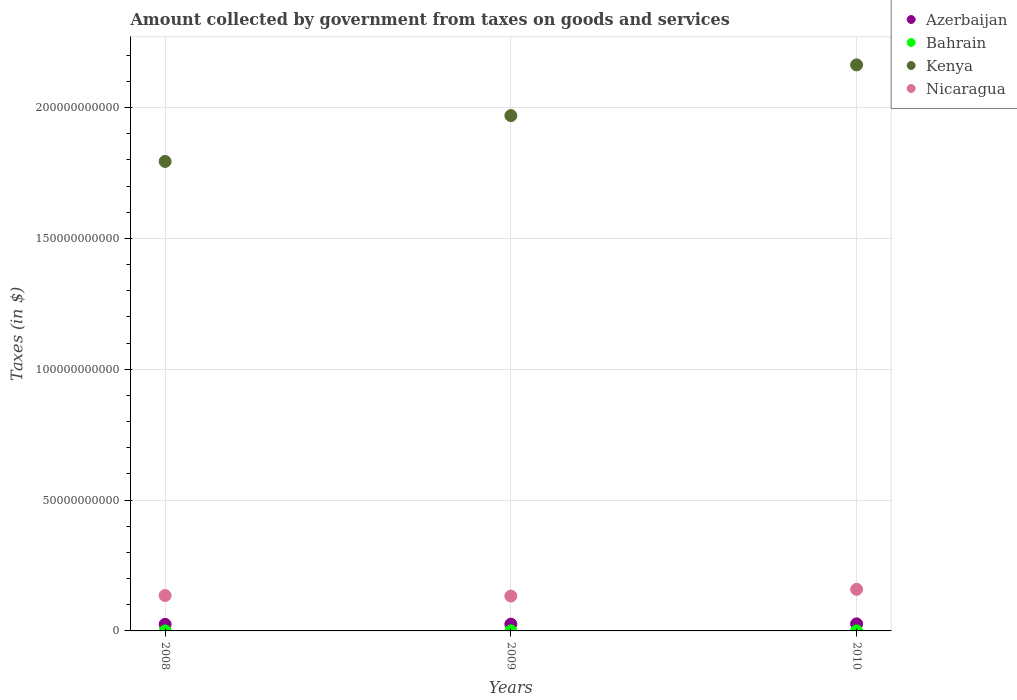How many different coloured dotlines are there?
Offer a terse response. 4. What is the amount collected by government from taxes on goods and services in Bahrain in 2009?
Your response must be concise. 2.07e+07. Across all years, what is the maximum amount collected by government from taxes on goods and services in Nicaragua?
Your answer should be compact. 1.59e+1. Across all years, what is the minimum amount collected by government from taxes on goods and services in Bahrain?
Your response must be concise. 3.32e+06. What is the total amount collected by government from taxes on goods and services in Bahrain in the graph?
Offer a very short reply. 3.67e+07. What is the difference between the amount collected by government from taxes on goods and services in Kenya in 2009 and that in 2010?
Provide a succinct answer. -1.94e+1. What is the difference between the amount collected by government from taxes on goods and services in Nicaragua in 2009 and the amount collected by government from taxes on goods and services in Bahrain in 2008?
Make the answer very short. 1.33e+1. What is the average amount collected by government from taxes on goods and services in Azerbaijan per year?
Give a very brief answer. 2.60e+09. In the year 2010, what is the difference between the amount collected by government from taxes on goods and services in Kenya and amount collected by government from taxes on goods and services in Azerbaijan?
Give a very brief answer. 2.14e+11. What is the ratio of the amount collected by government from taxes on goods and services in Kenya in 2008 to that in 2009?
Keep it short and to the point. 0.91. What is the difference between the highest and the second highest amount collected by government from taxes on goods and services in Nicaragua?
Your answer should be very brief. 2.37e+09. What is the difference between the highest and the lowest amount collected by government from taxes on goods and services in Azerbaijan?
Keep it short and to the point. 1.93e+08. Is it the case that in every year, the sum of the amount collected by government from taxes on goods and services in Nicaragua and amount collected by government from taxes on goods and services in Azerbaijan  is greater than the sum of amount collected by government from taxes on goods and services in Kenya and amount collected by government from taxes on goods and services in Bahrain?
Offer a very short reply. Yes. Are the values on the major ticks of Y-axis written in scientific E-notation?
Offer a terse response. No. Does the graph contain any zero values?
Keep it short and to the point. No. Where does the legend appear in the graph?
Your answer should be very brief. Top right. How many legend labels are there?
Make the answer very short. 4. How are the legend labels stacked?
Your answer should be compact. Vertical. What is the title of the graph?
Offer a terse response. Amount collected by government from taxes on goods and services. What is the label or title of the X-axis?
Offer a very short reply. Years. What is the label or title of the Y-axis?
Give a very brief answer. Taxes (in $). What is the Taxes (in $) of Azerbaijan in 2008?
Offer a terse response. 2.50e+09. What is the Taxes (in $) in Bahrain in 2008?
Offer a terse response. 3.32e+06. What is the Taxes (in $) of Kenya in 2008?
Provide a succinct answer. 1.79e+11. What is the Taxes (in $) of Nicaragua in 2008?
Your answer should be compact. 1.35e+1. What is the Taxes (in $) in Azerbaijan in 2009?
Provide a short and direct response. 2.59e+09. What is the Taxes (in $) of Bahrain in 2009?
Give a very brief answer. 2.07e+07. What is the Taxes (in $) in Kenya in 2009?
Ensure brevity in your answer.  1.97e+11. What is the Taxes (in $) of Nicaragua in 2009?
Your response must be concise. 1.33e+1. What is the Taxes (in $) in Azerbaijan in 2010?
Offer a terse response. 2.70e+09. What is the Taxes (in $) in Bahrain in 2010?
Your response must be concise. 1.27e+07. What is the Taxes (in $) in Kenya in 2010?
Your answer should be compact. 2.16e+11. What is the Taxes (in $) in Nicaragua in 2010?
Provide a short and direct response. 1.59e+1. Across all years, what is the maximum Taxes (in $) in Azerbaijan?
Offer a very short reply. 2.70e+09. Across all years, what is the maximum Taxes (in $) in Bahrain?
Your response must be concise. 2.07e+07. Across all years, what is the maximum Taxes (in $) of Kenya?
Offer a very short reply. 2.16e+11. Across all years, what is the maximum Taxes (in $) of Nicaragua?
Give a very brief answer. 1.59e+1. Across all years, what is the minimum Taxes (in $) in Azerbaijan?
Give a very brief answer. 2.50e+09. Across all years, what is the minimum Taxes (in $) of Bahrain?
Your answer should be very brief. 3.32e+06. Across all years, what is the minimum Taxes (in $) of Kenya?
Your answer should be compact. 1.79e+11. Across all years, what is the minimum Taxes (in $) of Nicaragua?
Make the answer very short. 1.33e+1. What is the total Taxes (in $) in Azerbaijan in the graph?
Ensure brevity in your answer.  7.79e+09. What is the total Taxes (in $) of Bahrain in the graph?
Ensure brevity in your answer.  3.67e+07. What is the total Taxes (in $) of Kenya in the graph?
Provide a succinct answer. 5.93e+11. What is the total Taxes (in $) of Nicaragua in the graph?
Your answer should be compact. 4.27e+1. What is the difference between the Taxes (in $) of Azerbaijan in 2008 and that in 2009?
Make the answer very short. -9.02e+07. What is the difference between the Taxes (in $) in Bahrain in 2008 and that in 2009?
Offer a terse response. -1.74e+07. What is the difference between the Taxes (in $) in Kenya in 2008 and that in 2009?
Offer a very short reply. -1.75e+1. What is the difference between the Taxes (in $) of Nicaragua in 2008 and that in 2009?
Provide a short and direct response. 2.08e+08. What is the difference between the Taxes (in $) of Azerbaijan in 2008 and that in 2010?
Your answer should be compact. -1.93e+08. What is the difference between the Taxes (in $) of Bahrain in 2008 and that in 2010?
Provide a succinct answer. -9.39e+06. What is the difference between the Taxes (in $) of Kenya in 2008 and that in 2010?
Offer a terse response. -3.69e+1. What is the difference between the Taxes (in $) in Nicaragua in 2008 and that in 2010?
Offer a very short reply. -2.37e+09. What is the difference between the Taxes (in $) in Azerbaijan in 2009 and that in 2010?
Your answer should be very brief. -1.03e+08. What is the difference between the Taxes (in $) of Bahrain in 2009 and that in 2010?
Keep it short and to the point. 7.99e+06. What is the difference between the Taxes (in $) of Kenya in 2009 and that in 2010?
Your answer should be compact. -1.94e+1. What is the difference between the Taxes (in $) in Nicaragua in 2009 and that in 2010?
Your response must be concise. -2.58e+09. What is the difference between the Taxes (in $) in Azerbaijan in 2008 and the Taxes (in $) in Bahrain in 2009?
Provide a short and direct response. 2.48e+09. What is the difference between the Taxes (in $) in Azerbaijan in 2008 and the Taxes (in $) in Kenya in 2009?
Your answer should be compact. -1.94e+11. What is the difference between the Taxes (in $) of Azerbaijan in 2008 and the Taxes (in $) of Nicaragua in 2009?
Your answer should be very brief. -1.08e+1. What is the difference between the Taxes (in $) of Bahrain in 2008 and the Taxes (in $) of Kenya in 2009?
Your response must be concise. -1.97e+11. What is the difference between the Taxes (in $) of Bahrain in 2008 and the Taxes (in $) of Nicaragua in 2009?
Ensure brevity in your answer.  -1.33e+1. What is the difference between the Taxes (in $) of Kenya in 2008 and the Taxes (in $) of Nicaragua in 2009?
Your answer should be very brief. 1.66e+11. What is the difference between the Taxes (in $) in Azerbaijan in 2008 and the Taxes (in $) in Bahrain in 2010?
Keep it short and to the point. 2.49e+09. What is the difference between the Taxes (in $) in Azerbaijan in 2008 and the Taxes (in $) in Kenya in 2010?
Offer a terse response. -2.14e+11. What is the difference between the Taxes (in $) in Azerbaijan in 2008 and the Taxes (in $) in Nicaragua in 2010?
Offer a very short reply. -1.34e+1. What is the difference between the Taxes (in $) of Bahrain in 2008 and the Taxes (in $) of Kenya in 2010?
Keep it short and to the point. -2.16e+11. What is the difference between the Taxes (in $) of Bahrain in 2008 and the Taxes (in $) of Nicaragua in 2010?
Your answer should be very brief. -1.59e+1. What is the difference between the Taxes (in $) in Kenya in 2008 and the Taxes (in $) in Nicaragua in 2010?
Your response must be concise. 1.64e+11. What is the difference between the Taxes (in $) of Azerbaijan in 2009 and the Taxes (in $) of Bahrain in 2010?
Give a very brief answer. 2.58e+09. What is the difference between the Taxes (in $) in Azerbaijan in 2009 and the Taxes (in $) in Kenya in 2010?
Provide a succinct answer. -2.14e+11. What is the difference between the Taxes (in $) of Azerbaijan in 2009 and the Taxes (in $) of Nicaragua in 2010?
Make the answer very short. -1.33e+1. What is the difference between the Taxes (in $) in Bahrain in 2009 and the Taxes (in $) in Kenya in 2010?
Give a very brief answer. -2.16e+11. What is the difference between the Taxes (in $) of Bahrain in 2009 and the Taxes (in $) of Nicaragua in 2010?
Make the answer very short. -1.59e+1. What is the difference between the Taxes (in $) of Kenya in 2009 and the Taxes (in $) of Nicaragua in 2010?
Offer a terse response. 1.81e+11. What is the average Taxes (in $) of Azerbaijan per year?
Keep it short and to the point. 2.60e+09. What is the average Taxes (in $) in Bahrain per year?
Provide a short and direct response. 1.22e+07. What is the average Taxes (in $) of Kenya per year?
Keep it short and to the point. 1.98e+11. What is the average Taxes (in $) of Nicaragua per year?
Your answer should be compact. 1.42e+1. In the year 2008, what is the difference between the Taxes (in $) in Azerbaijan and Taxes (in $) in Bahrain?
Provide a succinct answer. 2.50e+09. In the year 2008, what is the difference between the Taxes (in $) of Azerbaijan and Taxes (in $) of Kenya?
Your response must be concise. -1.77e+11. In the year 2008, what is the difference between the Taxes (in $) of Azerbaijan and Taxes (in $) of Nicaragua?
Give a very brief answer. -1.10e+1. In the year 2008, what is the difference between the Taxes (in $) of Bahrain and Taxes (in $) of Kenya?
Provide a short and direct response. -1.79e+11. In the year 2008, what is the difference between the Taxes (in $) of Bahrain and Taxes (in $) of Nicaragua?
Provide a succinct answer. -1.35e+1. In the year 2008, what is the difference between the Taxes (in $) of Kenya and Taxes (in $) of Nicaragua?
Keep it short and to the point. 1.66e+11. In the year 2009, what is the difference between the Taxes (in $) of Azerbaijan and Taxes (in $) of Bahrain?
Give a very brief answer. 2.57e+09. In the year 2009, what is the difference between the Taxes (in $) in Azerbaijan and Taxes (in $) in Kenya?
Offer a very short reply. -1.94e+11. In the year 2009, what is the difference between the Taxes (in $) of Azerbaijan and Taxes (in $) of Nicaragua?
Provide a succinct answer. -1.07e+1. In the year 2009, what is the difference between the Taxes (in $) in Bahrain and Taxes (in $) in Kenya?
Ensure brevity in your answer.  -1.97e+11. In the year 2009, what is the difference between the Taxes (in $) in Bahrain and Taxes (in $) in Nicaragua?
Keep it short and to the point. -1.33e+1. In the year 2009, what is the difference between the Taxes (in $) of Kenya and Taxes (in $) of Nicaragua?
Make the answer very short. 1.84e+11. In the year 2010, what is the difference between the Taxes (in $) of Azerbaijan and Taxes (in $) of Bahrain?
Ensure brevity in your answer.  2.68e+09. In the year 2010, what is the difference between the Taxes (in $) of Azerbaijan and Taxes (in $) of Kenya?
Make the answer very short. -2.14e+11. In the year 2010, what is the difference between the Taxes (in $) of Azerbaijan and Taxes (in $) of Nicaragua?
Offer a very short reply. -1.32e+1. In the year 2010, what is the difference between the Taxes (in $) in Bahrain and Taxes (in $) in Kenya?
Offer a very short reply. -2.16e+11. In the year 2010, what is the difference between the Taxes (in $) in Bahrain and Taxes (in $) in Nicaragua?
Offer a very short reply. -1.59e+1. In the year 2010, what is the difference between the Taxes (in $) of Kenya and Taxes (in $) of Nicaragua?
Ensure brevity in your answer.  2.00e+11. What is the ratio of the Taxes (in $) in Azerbaijan in 2008 to that in 2009?
Offer a terse response. 0.97. What is the ratio of the Taxes (in $) in Bahrain in 2008 to that in 2009?
Give a very brief answer. 0.16. What is the ratio of the Taxes (in $) of Kenya in 2008 to that in 2009?
Ensure brevity in your answer.  0.91. What is the ratio of the Taxes (in $) of Nicaragua in 2008 to that in 2009?
Give a very brief answer. 1.02. What is the ratio of the Taxes (in $) of Azerbaijan in 2008 to that in 2010?
Offer a terse response. 0.93. What is the ratio of the Taxes (in $) of Bahrain in 2008 to that in 2010?
Your answer should be very brief. 0.26. What is the ratio of the Taxes (in $) of Kenya in 2008 to that in 2010?
Ensure brevity in your answer.  0.83. What is the ratio of the Taxes (in $) in Nicaragua in 2008 to that in 2010?
Offer a terse response. 0.85. What is the ratio of the Taxes (in $) of Azerbaijan in 2009 to that in 2010?
Make the answer very short. 0.96. What is the ratio of the Taxes (in $) in Bahrain in 2009 to that in 2010?
Offer a terse response. 1.63. What is the ratio of the Taxes (in $) in Kenya in 2009 to that in 2010?
Offer a very short reply. 0.91. What is the ratio of the Taxes (in $) of Nicaragua in 2009 to that in 2010?
Ensure brevity in your answer.  0.84. What is the difference between the highest and the second highest Taxes (in $) in Azerbaijan?
Your response must be concise. 1.03e+08. What is the difference between the highest and the second highest Taxes (in $) in Bahrain?
Keep it short and to the point. 7.99e+06. What is the difference between the highest and the second highest Taxes (in $) of Kenya?
Your answer should be very brief. 1.94e+1. What is the difference between the highest and the second highest Taxes (in $) of Nicaragua?
Provide a short and direct response. 2.37e+09. What is the difference between the highest and the lowest Taxes (in $) in Azerbaijan?
Provide a short and direct response. 1.93e+08. What is the difference between the highest and the lowest Taxes (in $) of Bahrain?
Offer a very short reply. 1.74e+07. What is the difference between the highest and the lowest Taxes (in $) in Kenya?
Your answer should be compact. 3.69e+1. What is the difference between the highest and the lowest Taxes (in $) in Nicaragua?
Provide a short and direct response. 2.58e+09. 